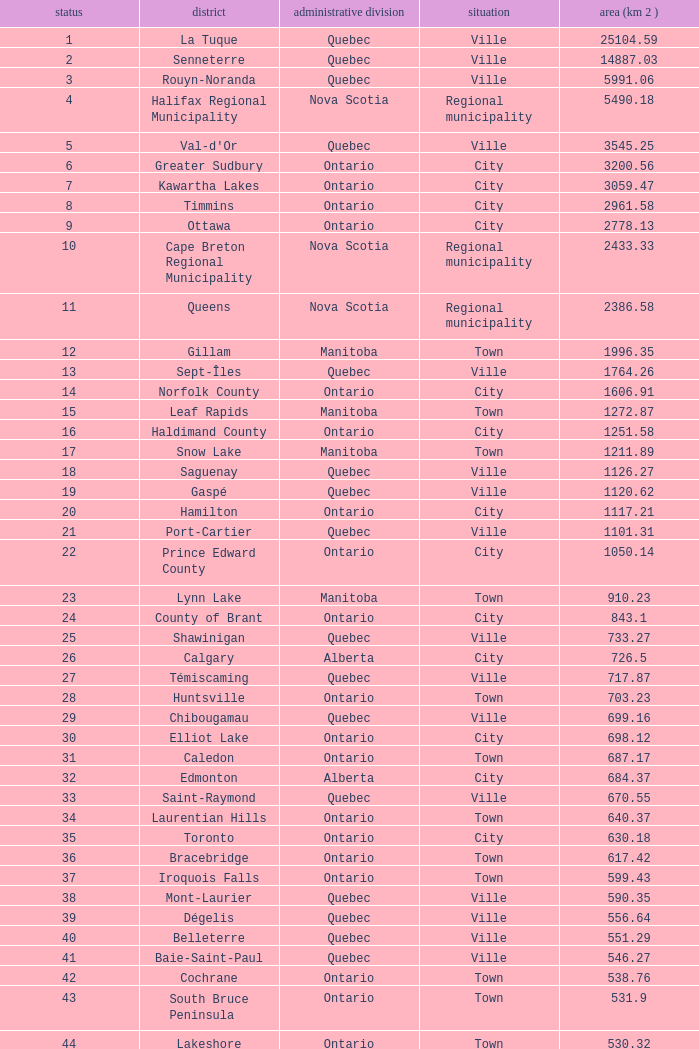What is the listed Status that has the Province of Ontario and Rank of 86? Town. 